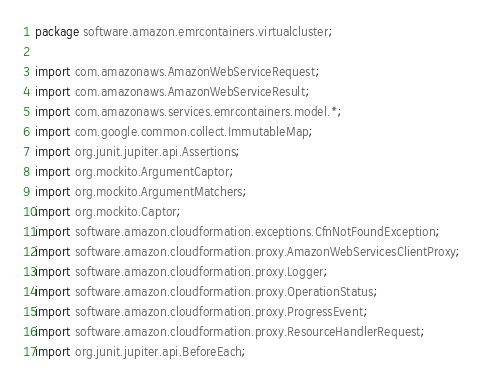Convert code to text. <code><loc_0><loc_0><loc_500><loc_500><_Java_>package software.amazon.emrcontainers.virtualcluster;

import com.amazonaws.AmazonWebServiceRequest;
import com.amazonaws.AmazonWebServiceResult;
import com.amazonaws.services.emrcontainers.model.*;
import com.google.common.collect.ImmutableMap;
import org.junit.jupiter.api.Assertions;
import org.mockito.ArgumentCaptor;
import org.mockito.ArgumentMatchers;
import org.mockito.Captor;
import software.amazon.cloudformation.exceptions.CfnNotFoundException;
import software.amazon.cloudformation.proxy.AmazonWebServicesClientProxy;
import software.amazon.cloudformation.proxy.Logger;
import software.amazon.cloudformation.proxy.OperationStatus;
import software.amazon.cloudformation.proxy.ProgressEvent;
import software.amazon.cloudformation.proxy.ResourceHandlerRequest;
import org.junit.jupiter.api.BeforeEach;</code> 